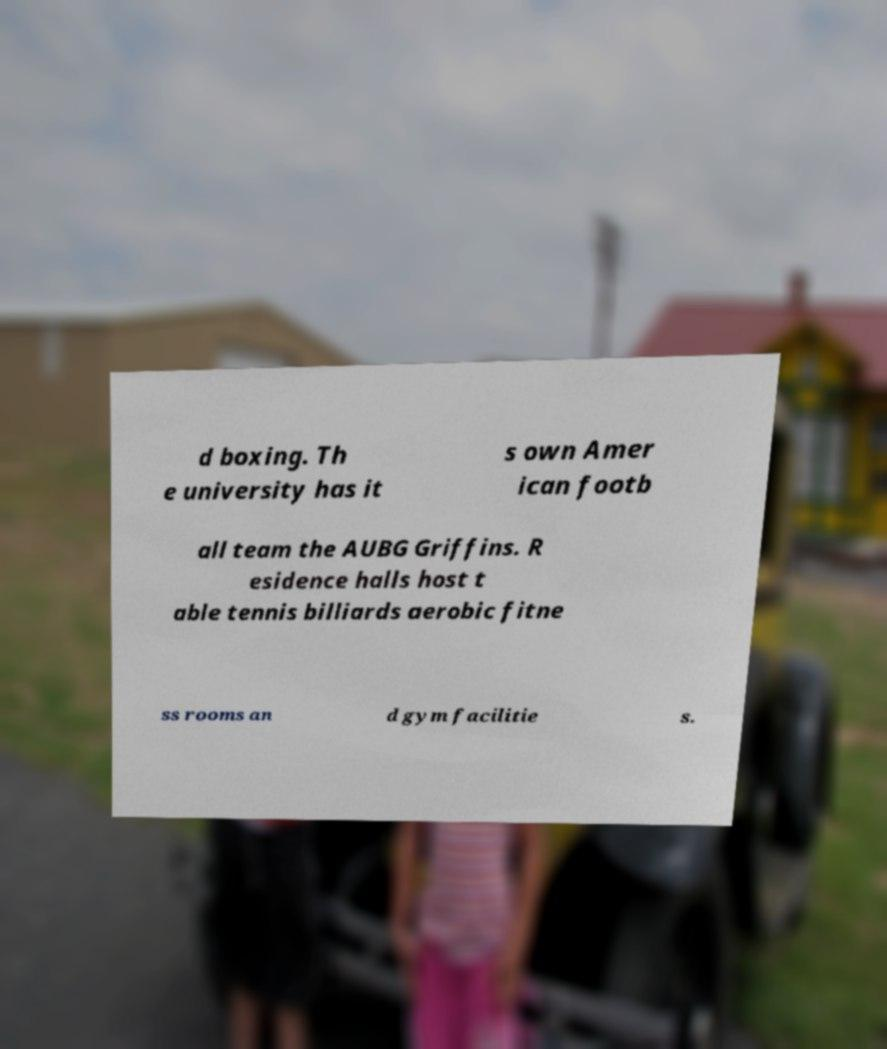What messages or text are displayed in this image? I need them in a readable, typed format. d boxing. Th e university has it s own Amer ican footb all team the AUBG Griffins. R esidence halls host t able tennis billiards aerobic fitne ss rooms an d gym facilitie s. 